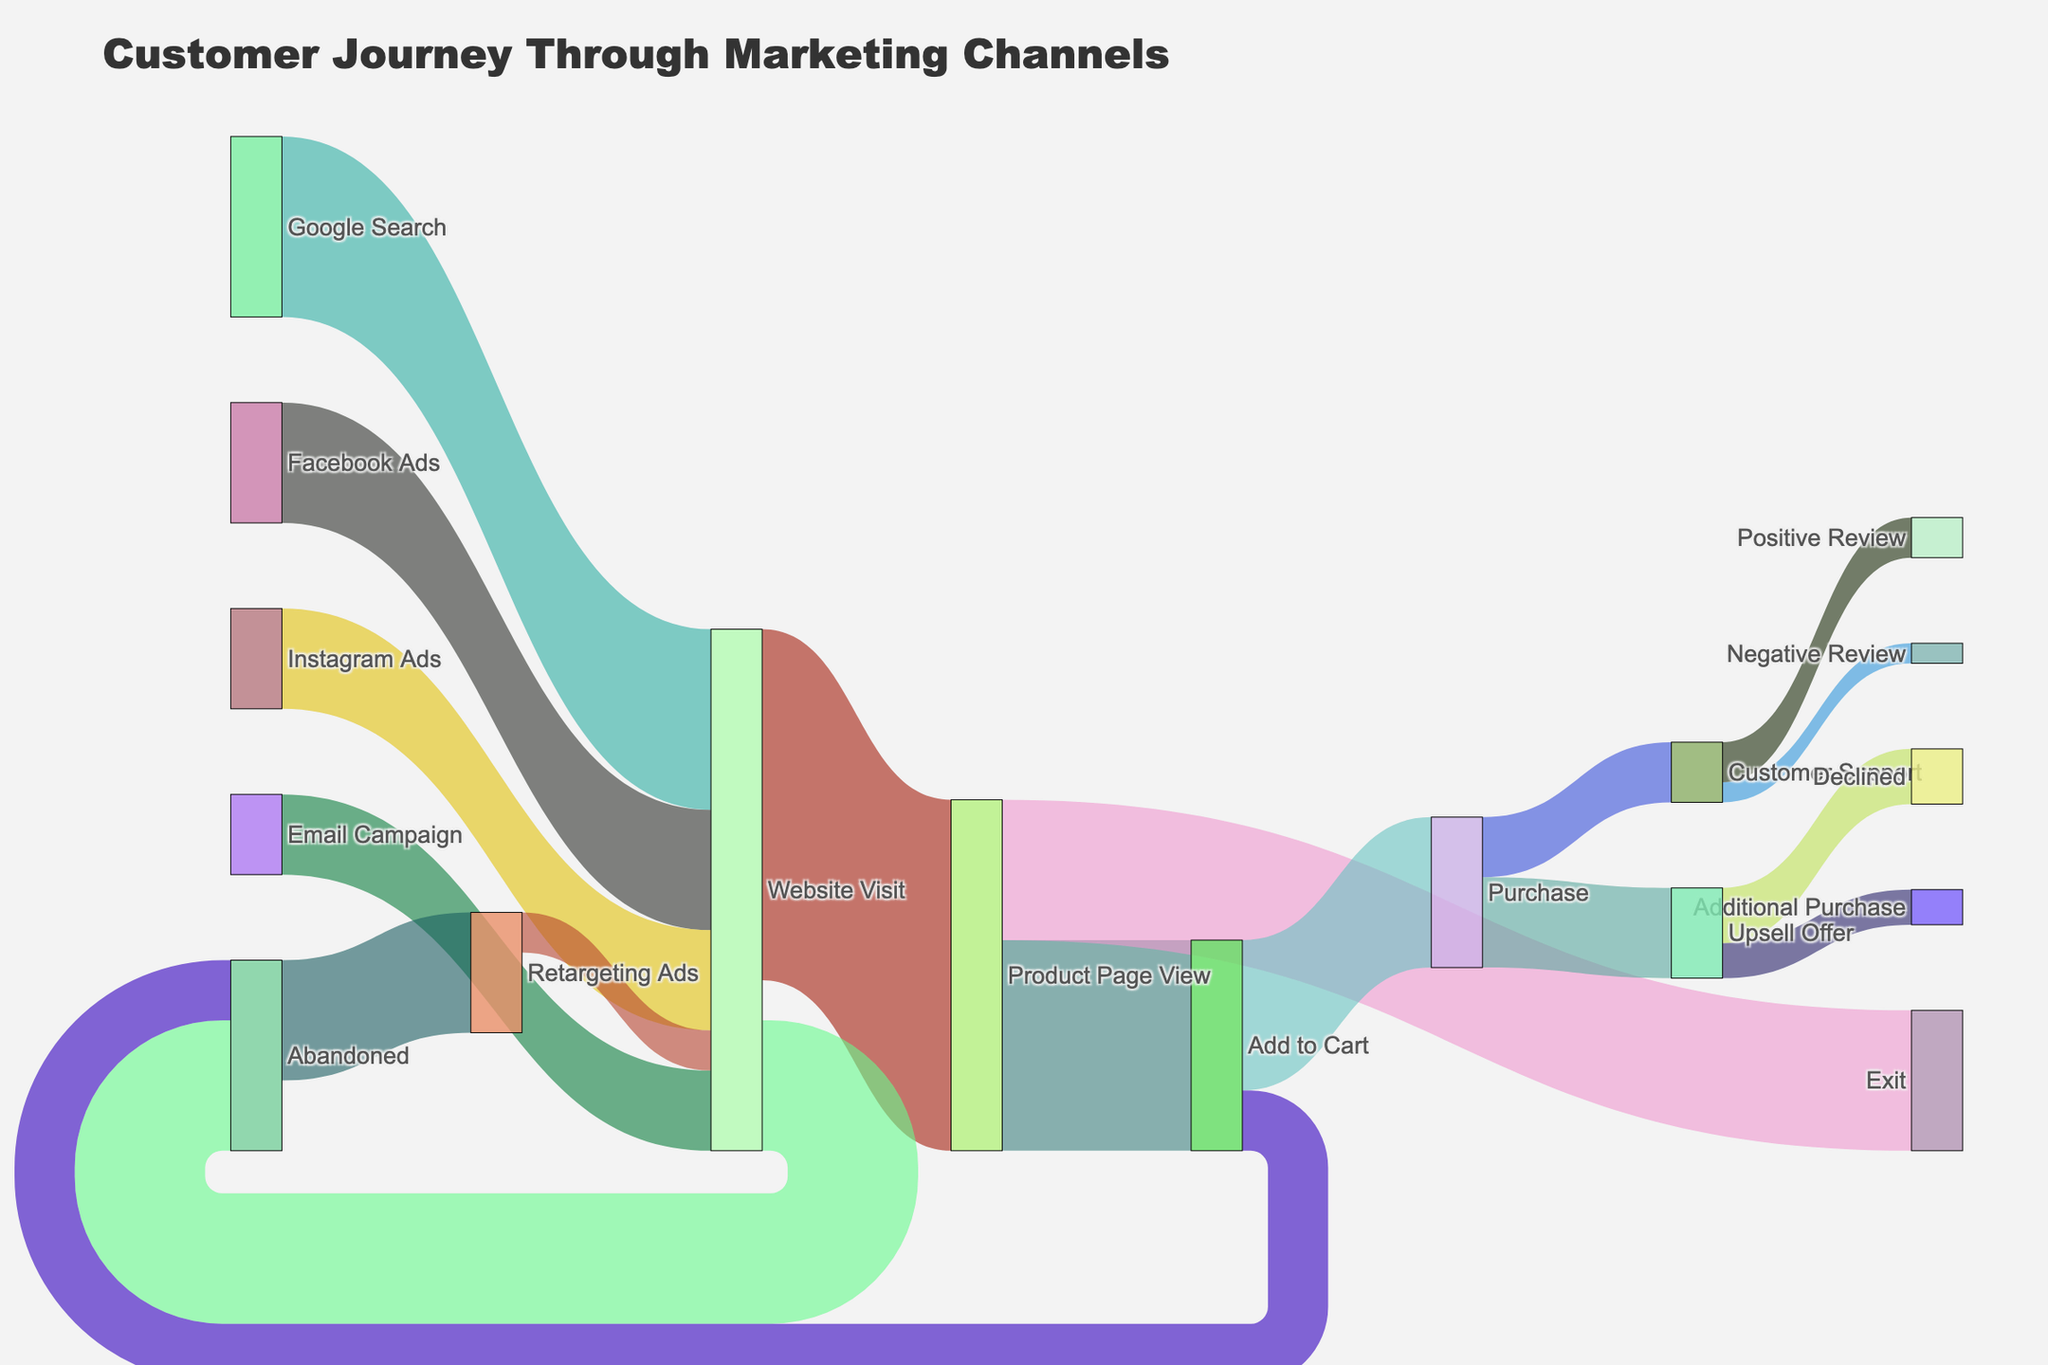Which marketing channel drives the most visits to the website? The Google Search channel has the highest value (1800), indicating it drives the most visits to the website.
Answer: Google Search How many website visitors abandon the site before viewing the product page? The number of website visitors that abandon the site before viewing the product page is represented by the link with the target "Abandoned" and the value is 1300.
Answer: 1300 What is the total number of customers who added the product to their cart? The number of customers who added the product to their cart can be found in the link with the target "Add to Cart" and the value is 2100.
Answer: 2100 How many purchases result from Ads on Facebook? Start with the number of website visits from Facebook Ads (1200), follow the links through the customer journey: "Website Visit" to "Product Page View" to "Add to Cart" to "Purchase". Since the Sankey Diagram doesn't show the exact flow through all these stages except in totals, we can't determine the exact number just for Facebook. This question is not directly answerable with the given data.
Answer: Not directly answerable Do customers who encounter an Upsell Offer purchase additional products more or less often than they decline the offer? Compare the values for "Upsell Offer" to "Additional Purchase" (350) and "Upsell Offer" to "Declined" (550). Since 350 < 550, customers decline the offer more often than they purchase additional products.
Answer: Less often What is the ratio of website visits from email campaigns to those from Instagram ads? The number of website visits from email campaigns is 800, and from Instagram ads is 1000. The ratio is 800:1000 which simplifies to 4:5.
Answer: 4:5 How many total "Abandoned" instances occur, including from both the website and add-to-cart stages? Sum the values of "Website Visit" to "Abandoned" (1300) and "Add to Cart" to "Abandoned" (600). Thus, the total is 1300 + 600 = 1900.
Answer: 1900 Which path(s) have the highest drop-off rate where no further interaction is recorded? Look for paths with high values ending in "Exit" or "Abandoned". "Website Visit" to "Abandoned" (1300) and "Product Page View" to "Exit" (1400) have significant drop-offs, but "Product Page View" to "Exit" is the highest with 1400.
Answer: Product Page View to Exit How many purchases lead to a positive review from customer support? Track the purchases (1500) to Customer Support (600) then to Positive Review (400). A total of 400 purchases lead to positive reviews.
Answer: 400 